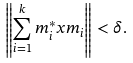Convert formula to latex. <formula><loc_0><loc_0><loc_500><loc_500>\left \| \sum _ { i = 1 } ^ { k } m _ { i } ^ { * } x m _ { i } \right \| < \delta .</formula> 